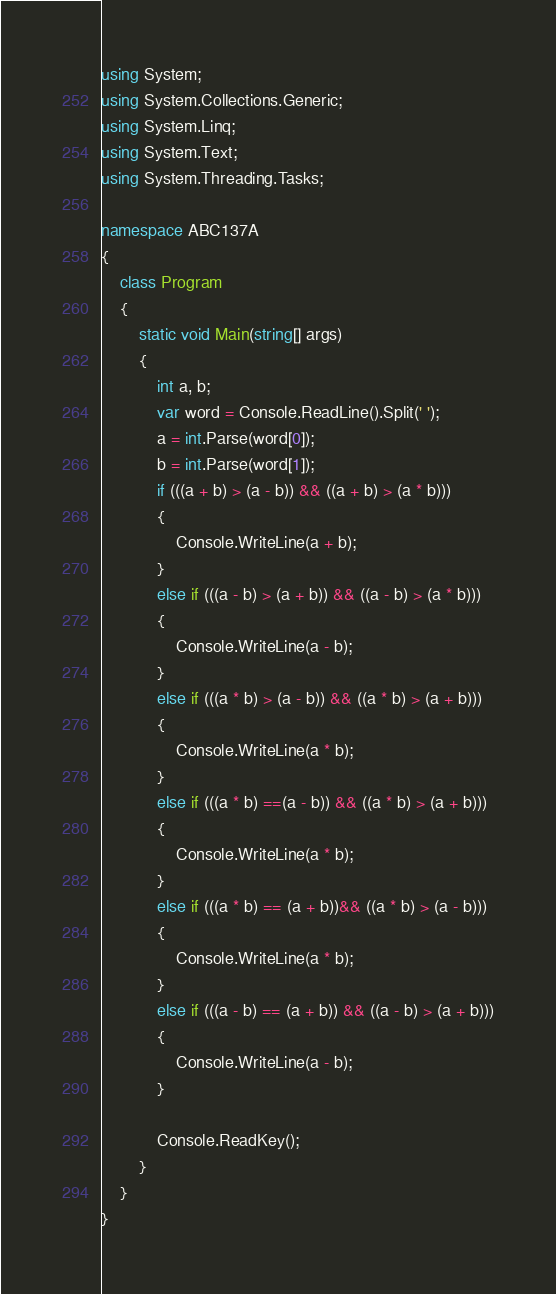<code> <loc_0><loc_0><loc_500><loc_500><_C#_>using System;
using System.Collections.Generic;
using System.Linq;
using System.Text;
using System.Threading.Tasks;

namespace ABC137A
{
    class Program
    {
        static void Main(string[] args)
        {
            int a, b;
            var word = Console.ReadLine().Split(' ');
            a = int.Parse(word[0]);
            b = int.Parse(word[1]);
            if (((a + b) > (a - b)) && ((a + b) > (a * b)))
            {
                Console.WriteLine(a + b);
            }
            else if (((a - b) > (a + b)) && ((a - b) > (a * b)))
            {
                Console.WriteLine(a - b);
            }
            else if (((a * b) > (a - b)) && ((a * b) > (a + b)))
            {
                Console.WriteLine(a * b);
            }
            else if (((a * b) ==(a - b)) && ((a * b) > (a + b)))
            {
                Console.WriteLine(a * b);
            }
            else if (((a * b) == (a + b))&& ((a * b) > (a - b)))
            {
                Console.WriteLine(a * b);
            }
            else if (((a - b) == (a + b)) && ((a - b) > (a + b)))
            {
                Console.WriteLine(a - b);
            }

            Console.ReadKey();
        }
    }
}</code> 